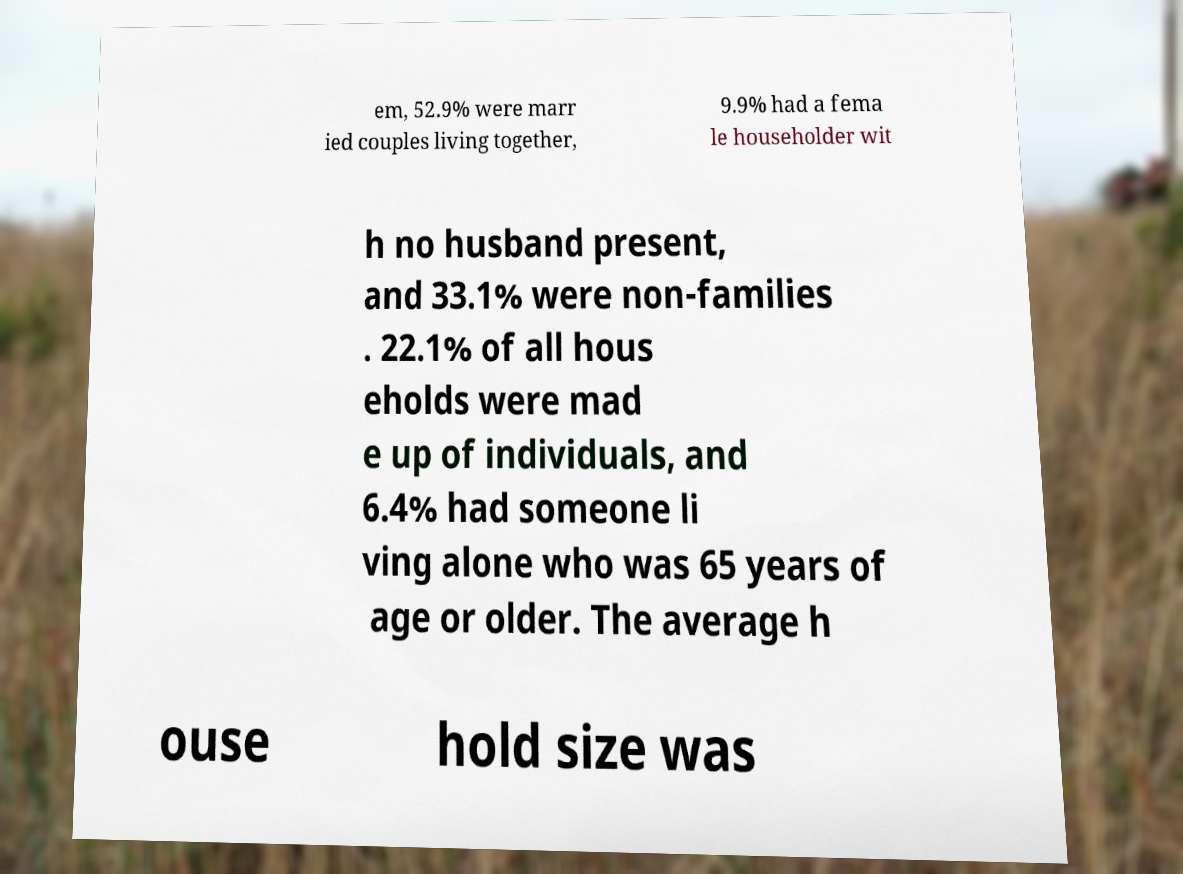There's text embedded in this image that I need extracted. Can you transcribe it verbatim? em, 52.9% were marr ied couples living together, 9.9% had a fema le householder wit h no husband present, and 33.1% were non-families . 22.1% of all hous eholds were mad e up of individuals, and 6.4% had someone li ving alone who was 65 years of age or older. The average h ouse hold size was 